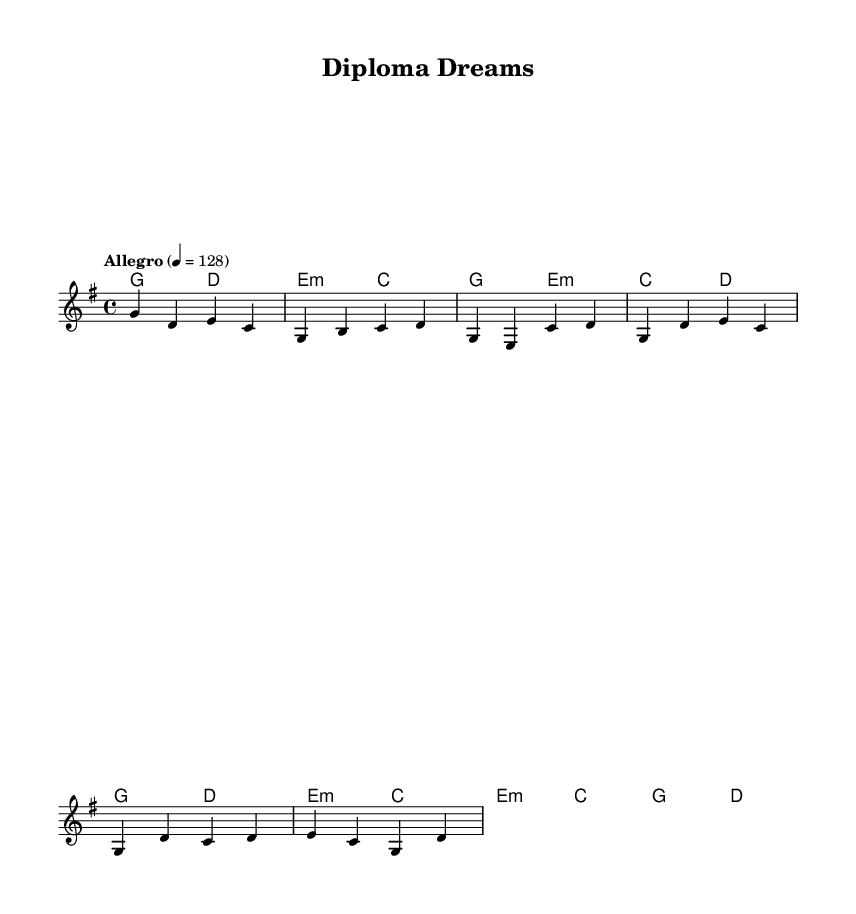What is the key signature of this music? The key signature is G major, which has one sharp (F#) indicated at the start of the staff.
Answer: G major What is the time signature of this music? The time signature is 4/4, meaning there are four beats in each measure, and the quarter note gets one beat. This can be seen at the beginning of the score, right after the key signature.
Answer: 4/4 What is the tempo indicated for this piece? The tempo is marked as Allegro, with a tempo of 128 beats per minute, indicating a fast pace. This is noted at the beginning of the score beneath the key signature.
Answer: Allegro 128 How many measures are in the verse? The verse consists of 4 measures, as indicated by the notation and the grouping of the musical phrases used in the verse section.
Answer: 4 What chords are used in the chorus? The chorus uses the chords G major, D major, E minor, and C major, which can be seen listed in the chord mode part of the score above the melody line.
Answer: G, D, E minor, C What is the overall theme of the song? The theme of the song is about achieving academic success and new beginnings, as reflected in the lyrics discussing transforming one's life and pursuing dreams.
Answer: Academic success and new beginnings What instruments are typically used in Country Rock music that might fit this piece? Typical instruments include electric guitar, acoustic guitar, bass guitar, and drums, which are common in Country Rock arrangement to create an upbeat sound.
Answer: Electric guitar, acoustic guitar, bass guitar, drums 